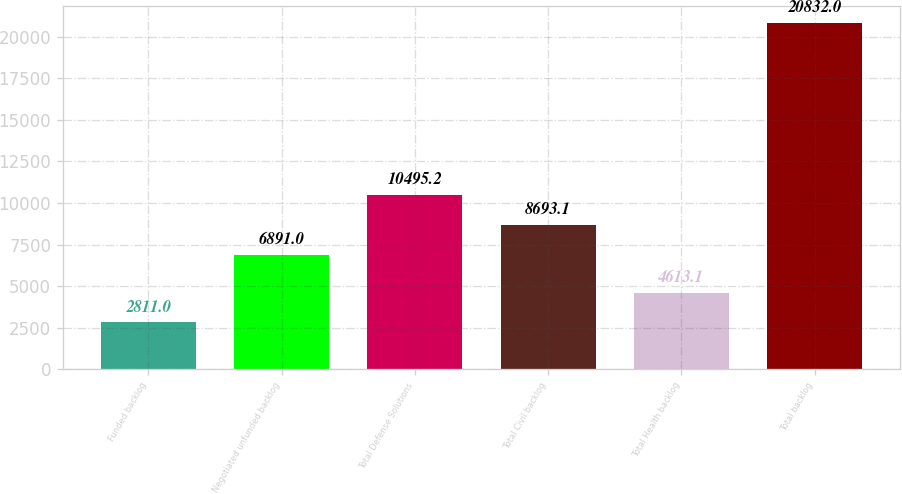Convert chart to OTSL. <chart><loc_0><loc_0><loc_500><loc_500><bar_chart><fcel>Funded backlog<fcel>Negotiated unfunded backlog<fcel>Total Defense Solutions<fcel>Total Civil backlog<fcel>Total Health backlog<fcel>Total backlog<nl><fcel>2811<fcel>6891<fcel>10495.2<fcel>8693.1<fcel>4613.1<fcel>20832<nl></chart> 